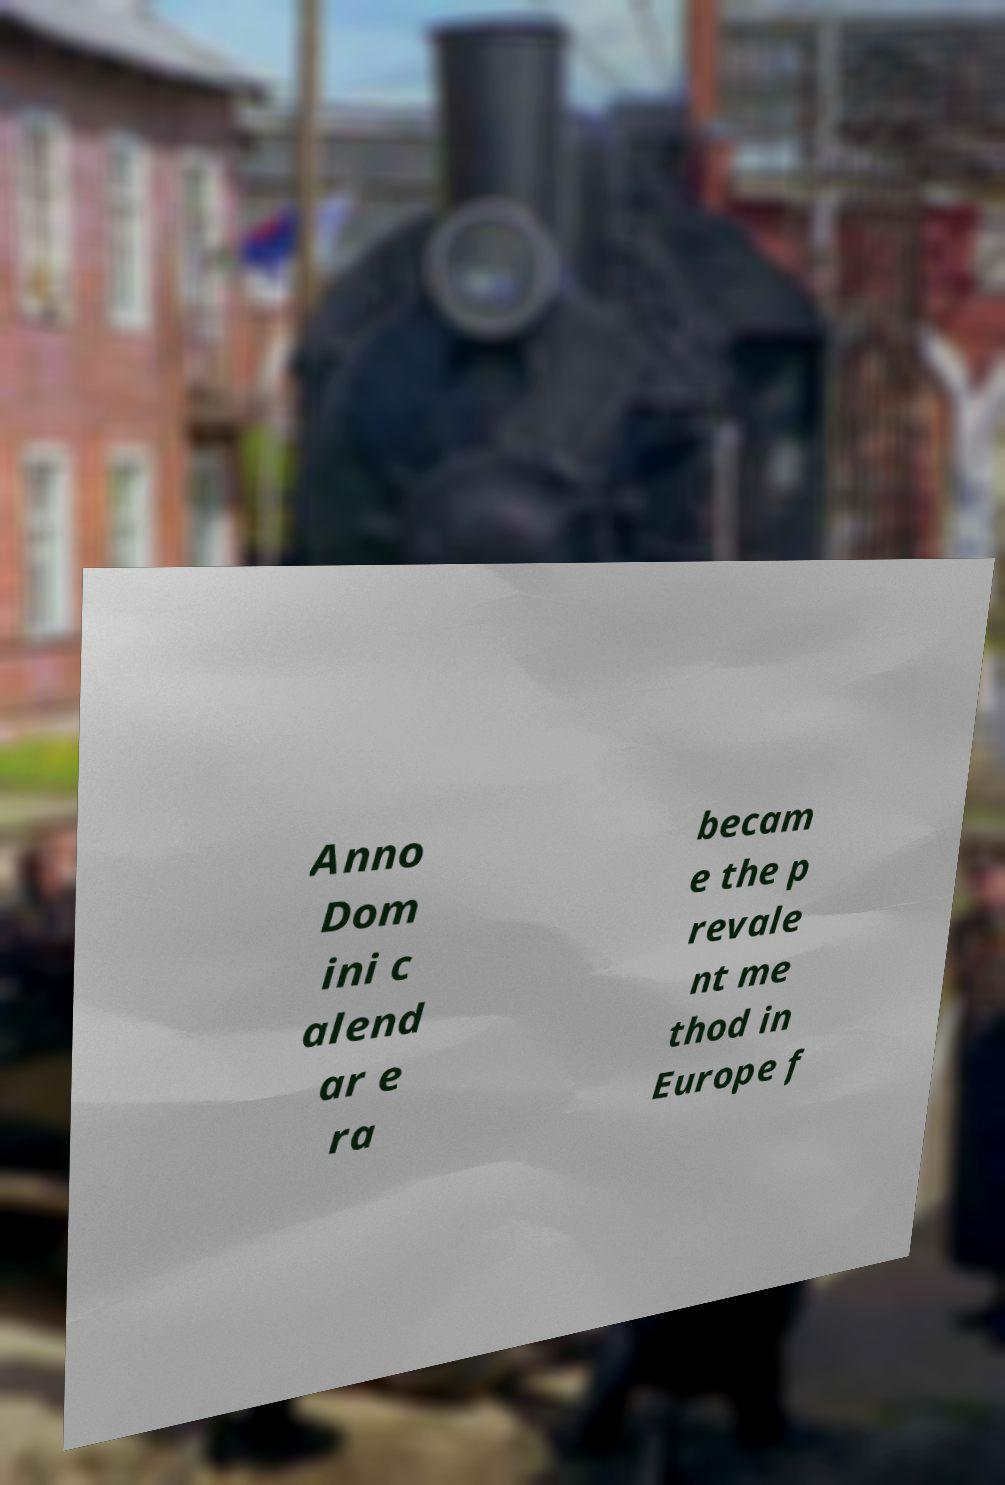Could you extract and type out the text from this image? Anno Dom ini c alend ar e ra becam e the p revale nt me thod in Europe f 